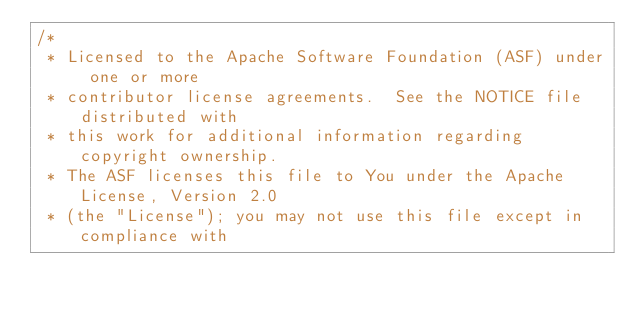Convert code to text. <code><loc_0><loc_0><loc_500><loc_500><_Scala_>/*
 * Licensed to the Apache Software Foundation (ASF) under one or more
 * contributor license agreements.  See the NOTICE file distributed with
 * this work for additional information regarding copyright ownership.
 * The ASF licenses this file to You under the Apache License, Version 2.0
 * (the "License"); you may not use this file except in compliance with</code> 